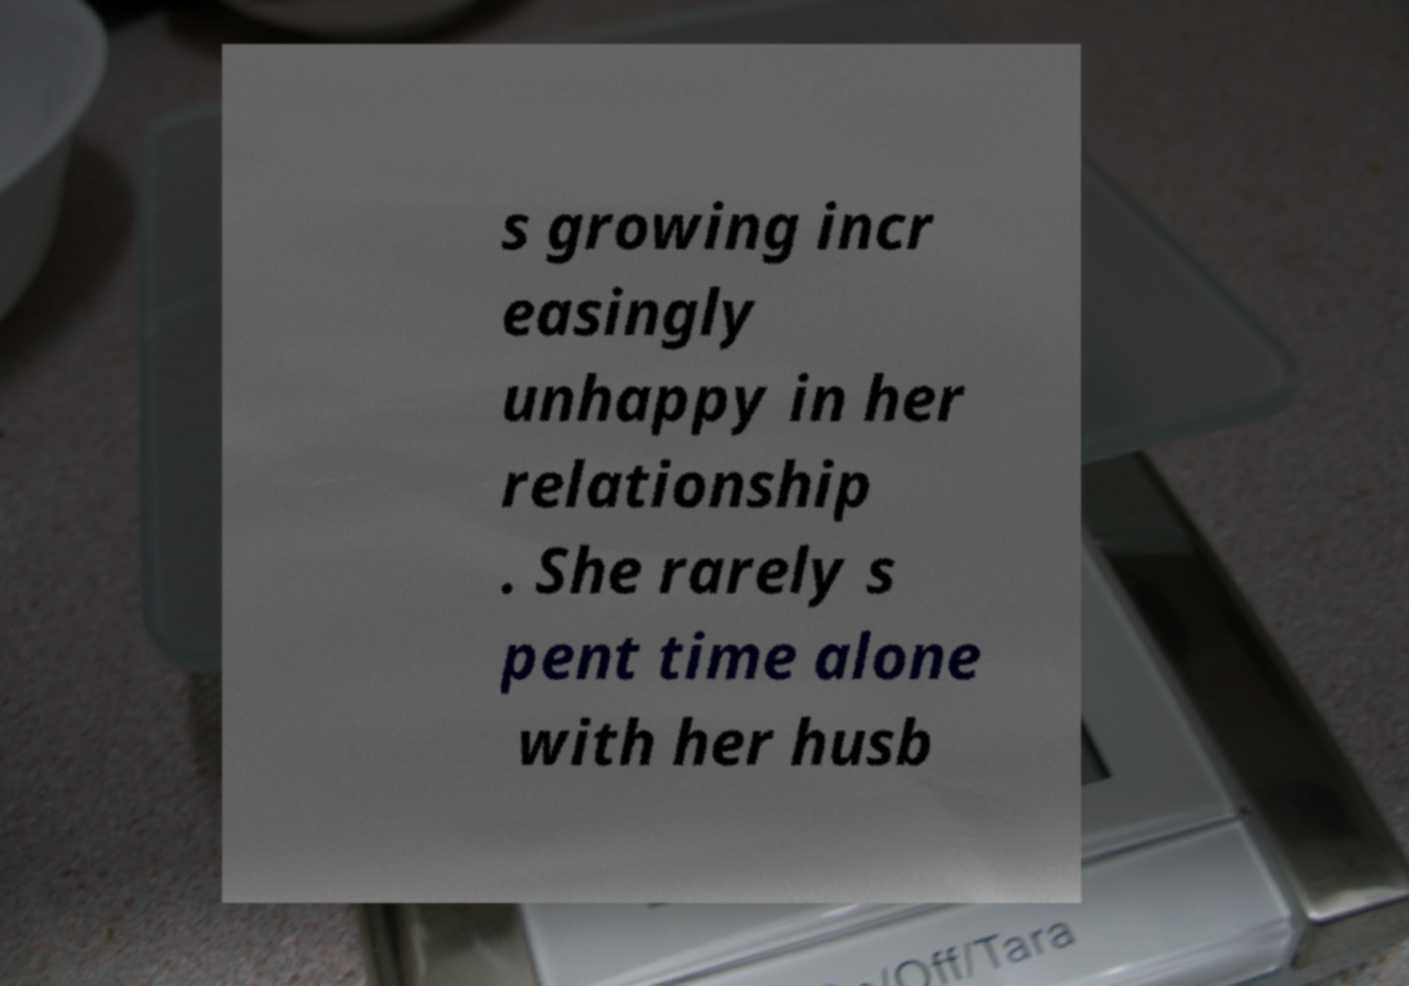Can you accurately transcribe the text from the provided image for me? s growing incr easingly unhappy in her relationship . She rarely s pent time alone with her husb 